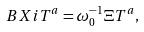Convert formula to latex. <formula><loc_0><loc_0><loc_500><loc_500>\ B X i T ^ { a } = \omega _ { 0 } ^ { - 1 } \Xi T ^ { a } ,</formula> 